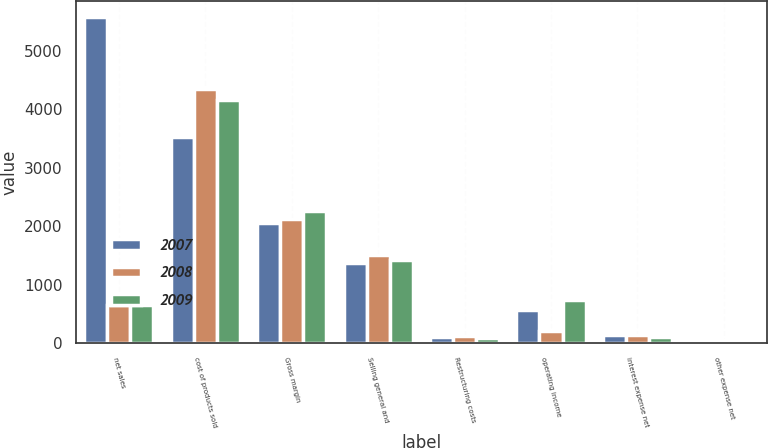<chart> <loc_0><loc_0><loc_500><loc_500><stacked_bar_chart><ecel><fcel>net sales<fcel>cost of products sold<fcel>Gross margin<fcel>Selling general and<fcel>Restructuring costs<fcel>operating income<fcel>interest expense net<fcel>other expense net<nl><fcel>2007<fcel>5577.6<fcel>3528.1<fcel>2049.5<fcel>1374.6<fcel>100<fcel>574.9<fcel>140<fcel>6.7<nl><fcel>2008<fcel>657.6<fcel>4347.4<fcel>2123.2<fcel>1502.7<fcel>120.3<fcel>200.8<fcel>137.9<fcel>59.1<nl><fcel>2009<fcel>657.6<fcel>4150.1<fcel>2257.2<fcel>1430.9<fcel>86<fcel>740.3<fcel>104.1<fcel>4.2<nl></chart> 